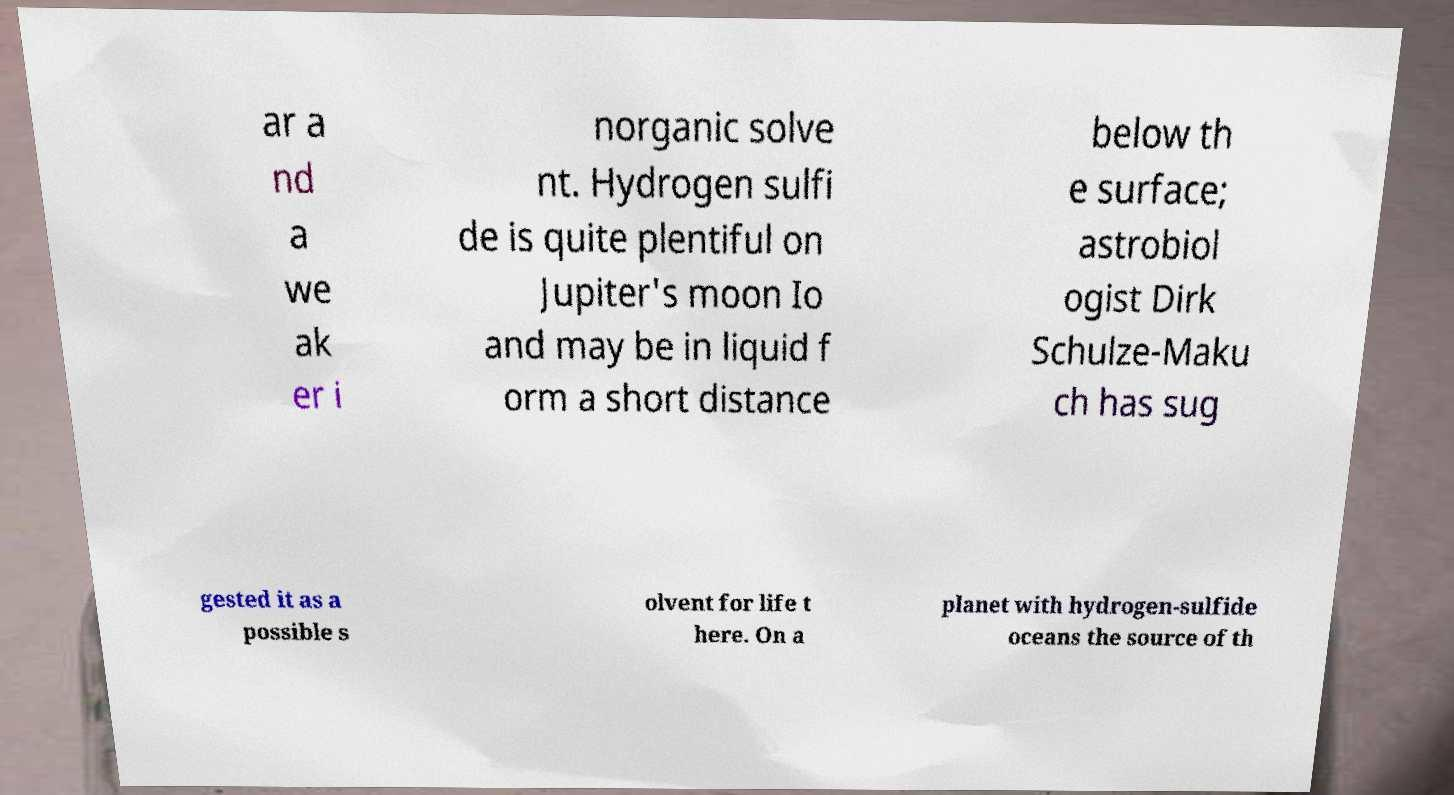Could you extract and type out the text from this image? ar a nd a we ak er i norganic solve nt. Hydrogen sulfi de is quite plentiful on Jupiter's moon Io and may be in liquid f orm a short distance below th e surface; astrobiol ogist Dirk Schulze-Maku ch has sug gested it as a possible s olvent for life t here. On a planet with hydrogen-sulfide oceans the source of th 